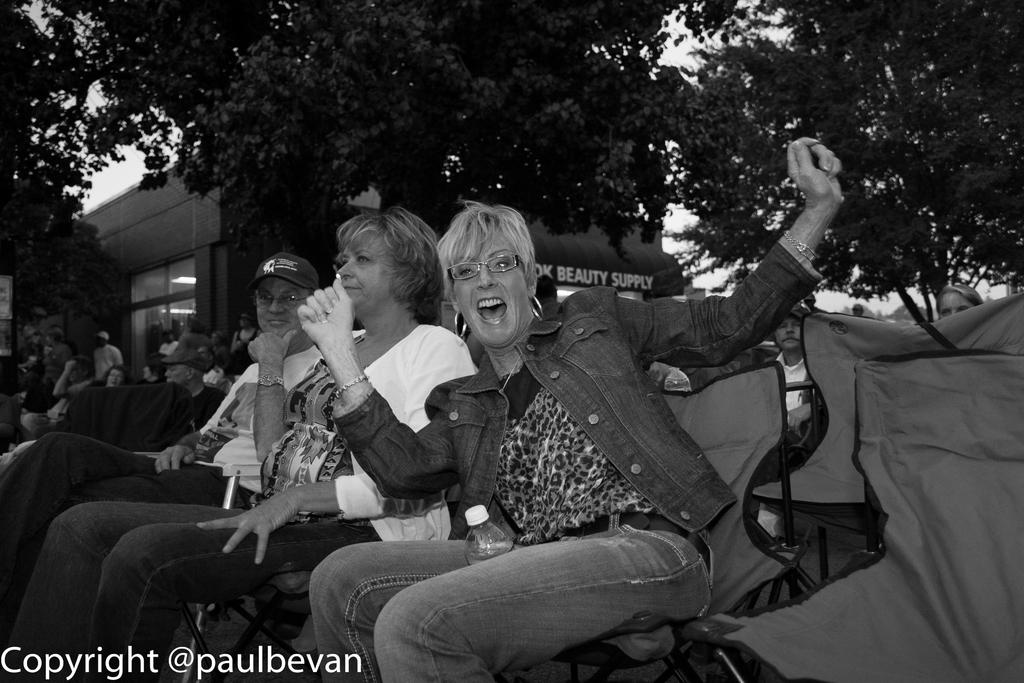What are the people in the image doing? The people in the image are sitting on chairs. What can be seen in the background of the image? There is a building in the background of the image. What type of natural elements are present in the image? Trees are present in the image. Where is the text located in the image? The text is at the left bottom of the image. How does the scale help the people in the image? There is no scale present in the image, so it cannot help the people in any way. 